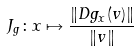Convert formula to latex. <formula><loc_0><loc_0><loc_500><loc_500>J _ { g } \colon x \mapsto \frac { \| D g _ { x } ( v ) \| } { \| v \| }</formula> 